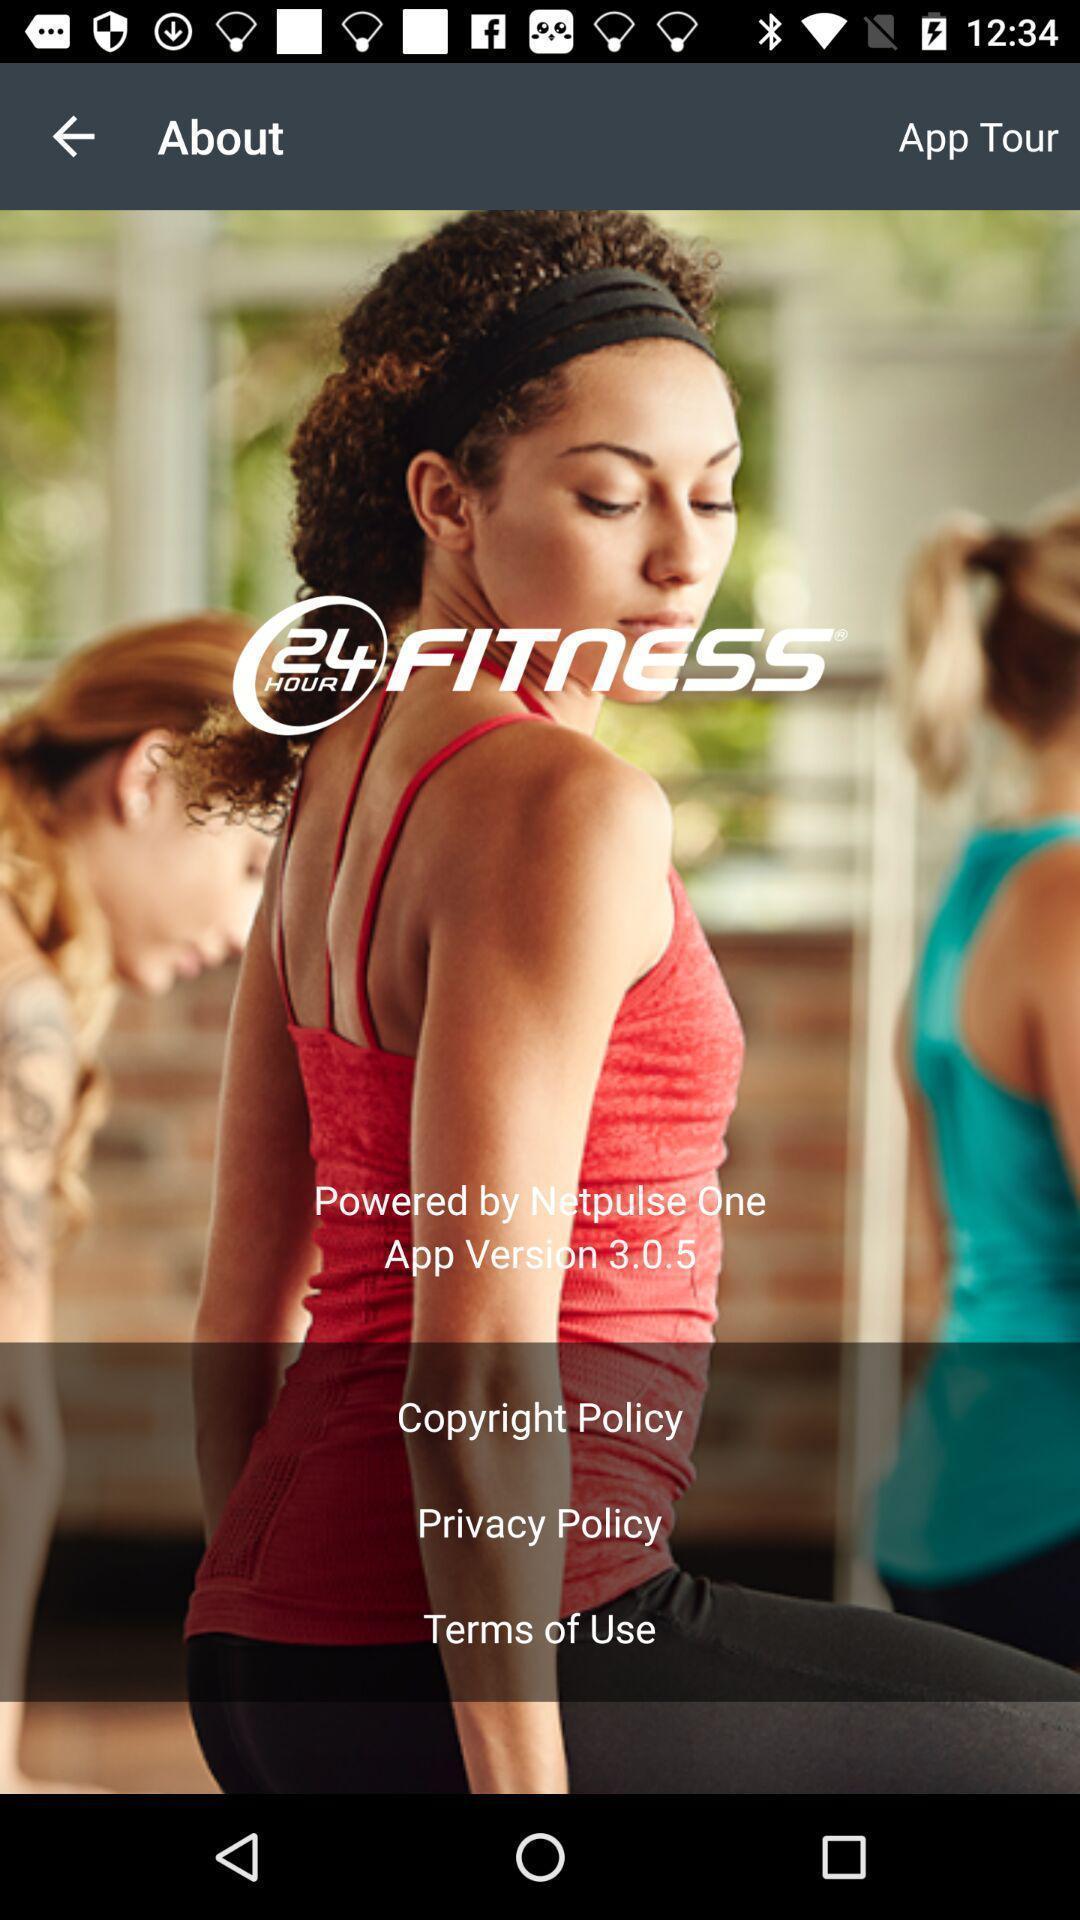Give me a narrative description of this picture. Window displaying a fitness app. 